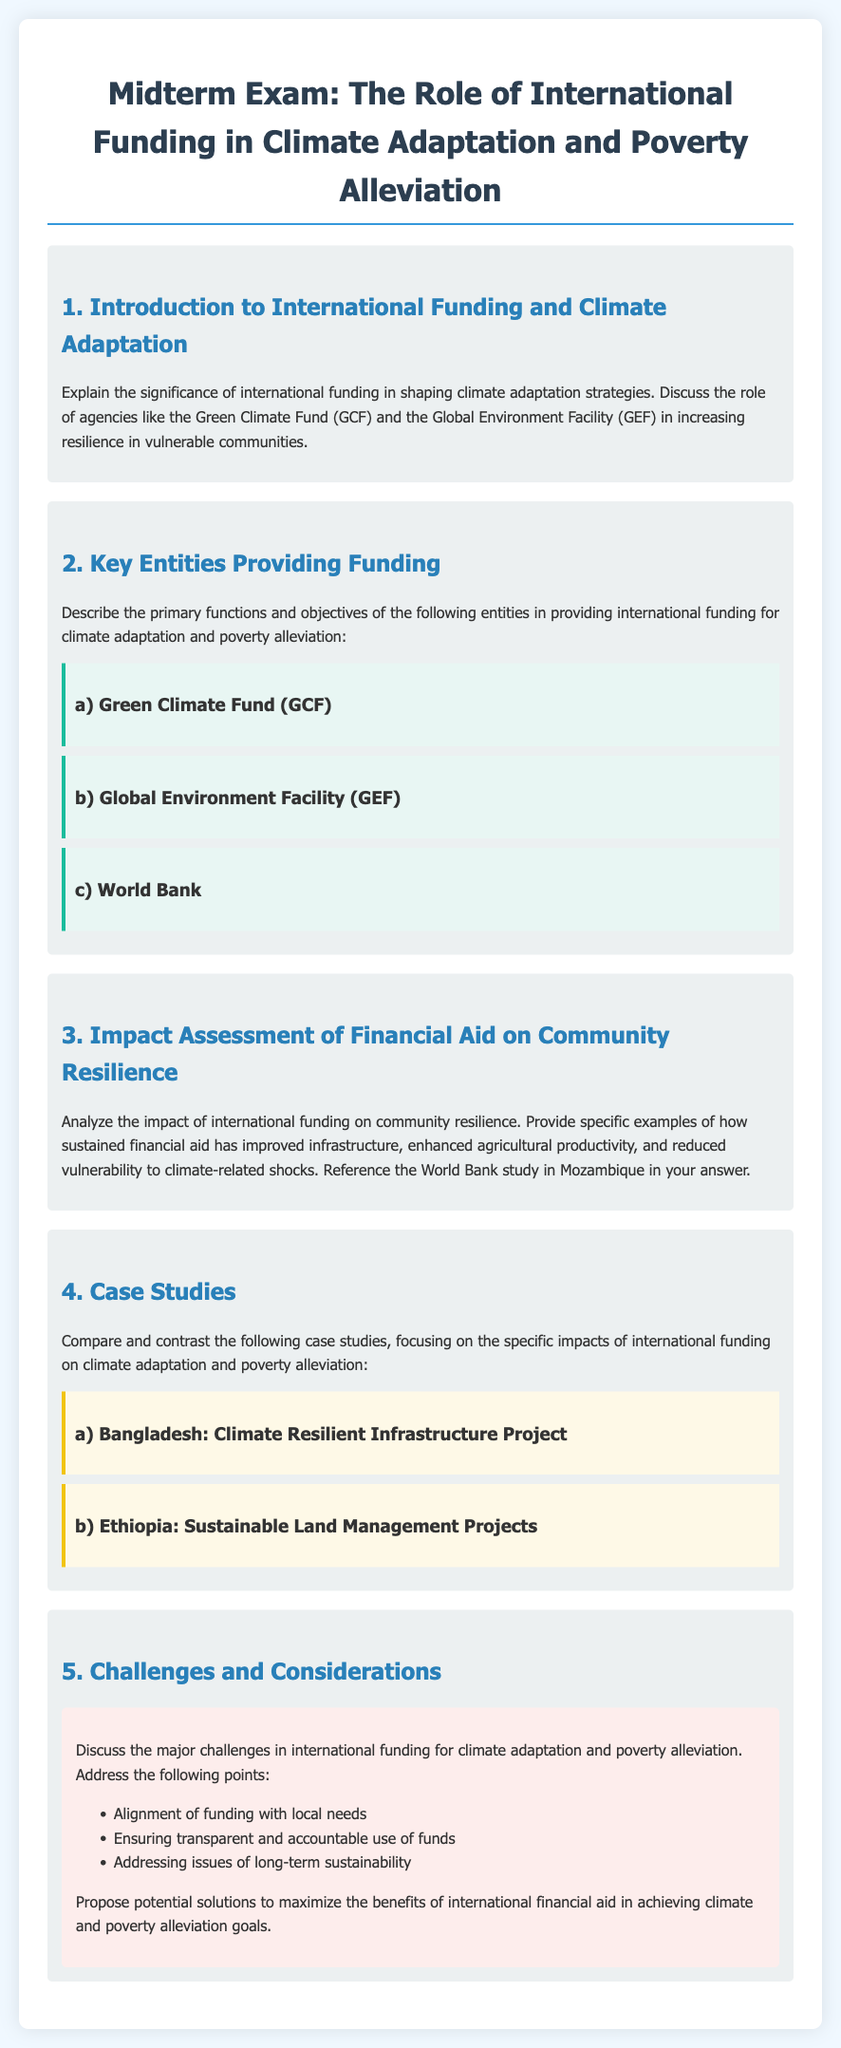What is the title of the midterm exam? The title of the midterm exam is explicitly stated in the document as "Midterm Exam: The Role of International Funding in Climate Adaptation and Poverty Alleviation."
Answer: Midterm Exam: The Role of International Funding in Climate Adaptation and Poverty Alleviation What is one of the organizations mentioned that provides international funding? The document lists several organizations, one of which is the Green Climate Fund (GCF) as a key entity providing funding.
Answer: Green Climate Fund (GCF) What is discussed in question 3 of the exam? Question 3 focuses on analyzing the impact of international funding on community resilience and references a specific study conducted by the World Bank in Mozambique.
Answer: Impact assessment of financial aid on community resilience Which country is associated with the Climate Resilient Infrastructure Project? The document mentions Bangladesh in relation to the Climate Resilient Infrastructure Project as a part of the case studies.
Answer: Bangladesh List one major challenge in international funding for climate adaptation discussed in question 5. The document mentions several challenges, one of which is the alignment of funding with local needs.
Answer: Alignment of funding with local needs What type of questions are included in the midterm exam? The midterm exam includes both short-answer questions and case study comparisons, as indicated in the sections throughout the document.
Answer: Short-answer questions and case study comparisons How many case studies are compared in the exam? The document states that two case studies are focused upon (Bangladesh and Ethiopia) in the case study section of the exam.
Answer: Two case studies What does the document suggest as a potential area of improvement in international funding? The document mentions ensuring transparent and accountable use of funds as a key area that requires attention and improvement in the context of international funding.
Answer: Ensuring transparent and accountable use of funds 